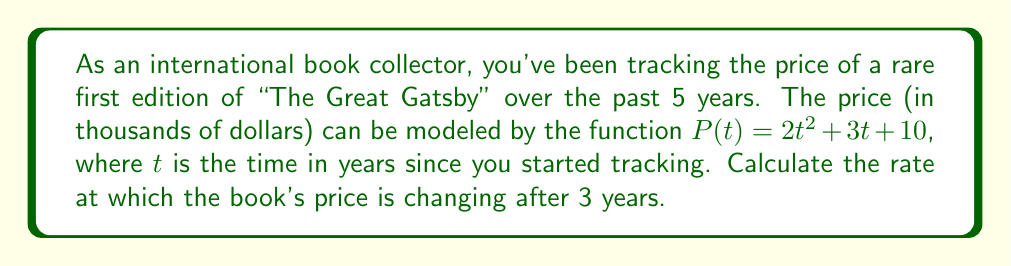Solve this math problem. To find the rate at which the book's price is changing after 3 years, we need to calculate the derivative of the price function $P(t)$ and evaluate it at $t=3$. Here's the step-by-step process:

1. Given price function: $P(t) = 2t^2 + 3t + 10$

2. Calculate the derivative $P'(t)$:
   $P'(t) = \frac{d}{dt}(2t^2 + 3t + 10)$
   $P'(t) = 4t + 3$

3. Evaluate $P'(t)$ at $t=3$:
   $P'(3) = 4(3) + 3$
   $P'(3) = 12 + 3 = 15$

The rate of change is measured in thousands of dollars per year, so we need to interpret the result accordingly.
Answer: $15,000 per year 